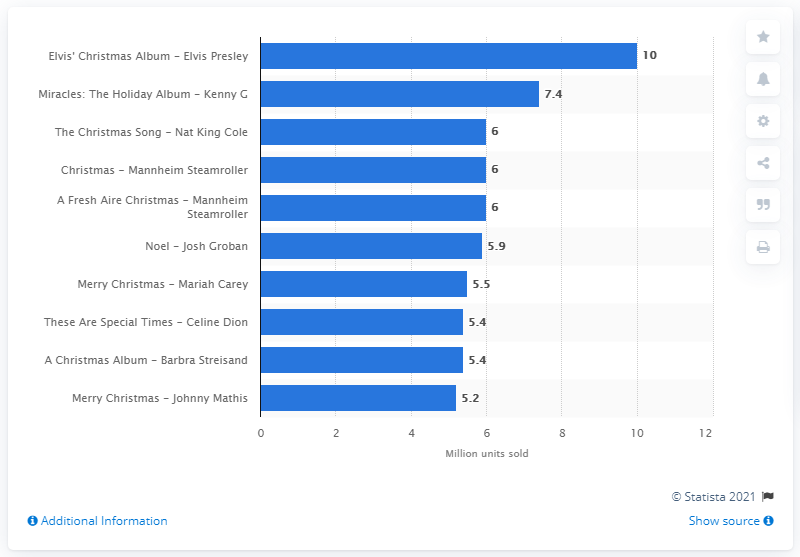Draw attention to some important aspects in this diagram. In 2016, Elvis Presley's Elvis' Christmas Album was sold a total of 10 units. 